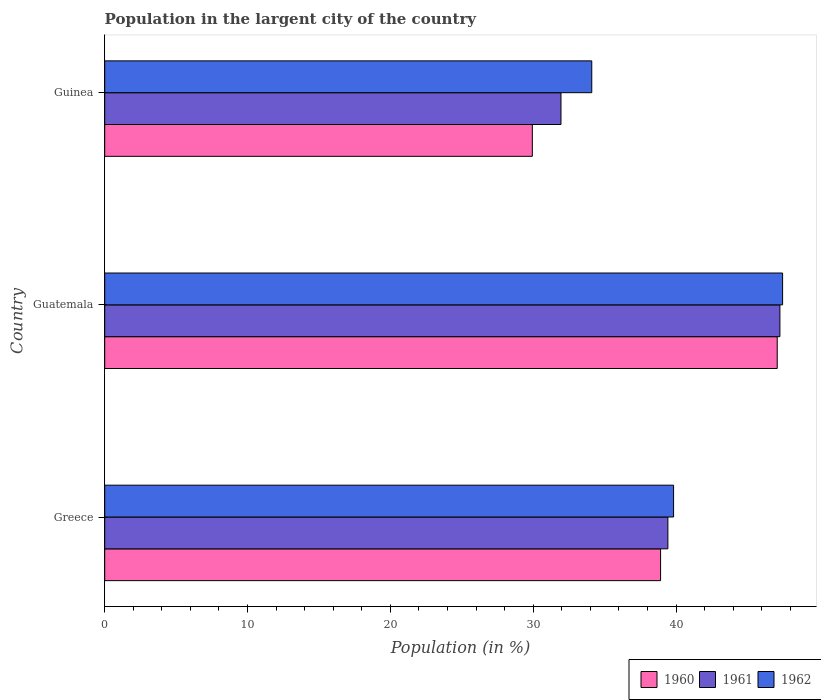How many different coloured bars are there?
Offer a very short reply. 3. How many groups of bars are there?
Provide a short and direct response. 3. Are the number of bars per tick equal to the number of legend labels?
Ensure brevity in your answer.  Yes. Are the number of bars on each tick of the Y-axis equal?
Provide a short and direct response. Yes. How many bars are there on the 2nd tick from the top?
Your answer should be very brief. 3. How many bars are there on the 3rd tick from the bottom?
Offer a very short reply. 3. What is the label of the 2nd group of bars from the top?
Offer a terse response. Guatemala. In how many cases, is the number of bars for a given country not equal to the number of legend labels?
Offer a terse response. 0. What is the percentage of population in the largent city in 1962 in Greece?
Your answer should be compact. 39.83. Across all countries, what is the maximum percentage of population in the largent city in 1962?
Your response must be concise. 47.46. Across all countries, what is the minimum percentage of population in the largent city in 1960?
Give a very brief answer. 29.94. In which country was the percentage of population in the largent city in 1962 maximum?
Make the answer very short. Guatemala. In which country was the percentage of population in the largent city in 1962 minimum?
Provide a succinct answer. Guinea. What is the total percentage of population in the largent city in 1960 in the graph?
Keep it short and to the point. 115.94. What is the difference between the percentage of population in the largent city in 1960 in Greece and that in Guinea?
Offer a terse response. 8.98. What is the difference between the percentage of population in the largent city in 1960 in Greece and the percentage of population in the largent city in 1962 in Guinea?
Ensure brevity in your answer.  4.82. What is the average percentage of population in the largent city in 1961 per country?
Your answer should be compact. 39.55. What is the difference between the percentage of population in the largent city in 1960 and percentage of population in the largent city in 1961 in Greece?
Ensure brevity in your answer.  -0.51. In how many countries, is the percentage of population in the largent city in 1961 greater than 44 %?
Offer a very short reply. 1. What is the ratio of the percentage of population in the largent city in 1960 in Guatemala to that in Guinea?
Keep it short and to the point. 1.57. Is the percentage of population in the largent city in 1962 in Guatemala less than that in Guinea?
Your answer should be very brief. No. Is the difference between the percentage of population in the largent city in 1960 in Greece and Guinea greater than the difference between the percentage of population in the largent city in 1961 in Greece and Guinea?
Your answer should be very brief. Yes. What is the difference between the highest and the second highest percentage of population in the largent city in 1962?
Offer a very short reply. 7.63. What is the difference between the highest and the lowest percentage of population in the largent city in 1960?
Provide a short and direct response. 17.15. Is the sum of the percentage of population in the largent city in 1962 in Greece and Guatemala greater than the maximum percentage of population in the largent city in 1960 across all countries?
Ensure brevity in your answer.  Yes. What does the 1st bar from the bottom in Guinea represents?
Give a very brief answer. 1960. Are all the bars in the graph horizontal?
Provide a short and direct response. Yes. Are the values on the major ticks of X-axis written in scientific E-notation?
Keep it short and to the point. No. Where does the legend appear in the graph?
Your answer should be very brief. Bottom right. How many legend labels are there?
Give a very brief answer. 3. What is the title of the graph?
Offer a terse response. Population in the largent city of the country. What is the label or title of the Y-axis?
Your answer should be very brief. Country. What is the Population (in %) in 1960 in Greece?
Make the answer very short. 38.92. What is the Population (in %) of 1961 in Greece?
Give a very brief answer. 39.43. What is the Population (in %) of 1962 in Greece?
Keep it short and to the point. 39.83. What is the Population (in %) in 1960 in Guatemala?
Offer a terse response. 47.08. What is the Population (in %) in 1961 in Guatemala?
Ensure brevity in your answer.  47.27. What is the Population (in %) in 1962 in Guatemala?
Give a very brief answer. 47.46. What is the Population (in %) in 1960 in Guinea?
Provide a short and direct response. 29.94. What is the Population (in %) in 1961 in Guinea?
Offer a very short reply. 31.94. What is the Population (in %) of 1962 in Guinea?
Your response must be concise. 34.1. Across all countries, what is the maximum Population (in %) of 1960?
Keep it short and to the point. 47.08. Across all countries, what is the maximum Population (in %) of 1961?
Your response must be concise. 47.27. Across all countries, what is the maximum Population (in %) in 1962?
Provide a succinct answer. 47.46. Across all countries, what is the minimum Population (in %) in 1960?
Your response must be concise. 29.94. Across all countries, what is the minimum Population (in %) in 1961?
Provide a short and direct response. 31.94. Across all countries, what is the minimum Population (in %) in 1962?
Give a very brief answer. 34.1. What is the total Population (in %) in 1960 in the graph?
Provide a succinct answer. 115.94. What is the total Population (in %) in 1961 in the graph?
Offer a terse response. 118.65. What is the total Population (in %) in 1962 in the graph?
Your answer should be compact. 121.39. What is the difference between the Population (in %) in 1960 in Greece and that in Guatemala?
Offer a very short reply. -8.17. What is the difference between the Population (in %) of 1961 in Greece and that in Guatemala?
Your answer should be compact. -7.84. What is the difference between the Population (in %) in 1962 in Greece and that in Guatemala?
Offer a terse response. -7.63. What is the difference between the Population (in %) of 1960 in Greece and that in Guinea?
Your answer should be compact. 8.98. What is the difference between the Population (in %) in 1961 in Greece and that in Guinea?
Give a very brief answer. 7.48. What is the difference between the Population (in %) of 1962 in Greece and that in Guinea?
Make the answer very short. 5.73. What is the difference between the Population (in %) in 1960 in Guatemala and that in Guinea?
Offer a terse response. 17.15. What is the difference between the Population (in %) in 1961 in Guatemala and that in Guinea?
Provide a short and direct response. 15.33. What is the difference between the Population (in %) in 1962 in Guatemala and that in Guinea?
Your answer should be very brief. 13.36. What is the difference between the Population (in %) in 1960 in Greece and the Population (in %) in 1961 in Guatemala?
Offer a very short reply. -8.35. What is the difference between the Population (in %) in 1960 in Greece and the Population (in %) in 1962 in Guatemala?
Provide a short and direct response. -8.54. What is the difference between the Population (in %) of 1961 in Greece and the Population (in %) of 1962 in Guatemala?
Provide a short and direct response. -8.03. What is the difference between the Population (in %) in 1960 in Greece and the Population (in %) in 1961 in Guinea?
Offer a very short reply. 6.97. What is the difference between the Population (in %) in 1960 in Greece and the Population (in %) in 1962 in Guinea?
Keep it short and to the point. 4.82. What is the difference between the Population (in %) of 1961 in Greece and the Population (in %) of 1962 in Guinea?
Make the answer very short. 5.33. What is the difference between the Population (in %) in 1960 in Guatemala and the Population (in %) in 1961 in Guinea?
Provide a succinct answer. 15.14. What is the difference between the Population (in %) of 1960 in Guatemala and the Population (in %) of 1962 in Guinea?
Provide a short and direct response. 12.98. What is the difference between the Population (in %) in 1961 in Guatemala and the Population (in %) in 1962 in Guinea?
Give a very brief answer. 13.17. What is the average Population (in %) in 1960 per country?
Provide a short and direct response. 38.65. What is the average Population (in %) in 1961 per country?
Ensure brevity in your answer.  39.55. What is the average Population (in %) of 1962 per country?
Your answer should be compact. 40.46. What is the difference between the Population (in %) in 1960 and Population (in %) in 1961 in Greece?
Keep it short and to the point. -0.51. What is the difference between the Population (in %) in 1960 and Population (in %) in 1962 in Greece?
Provide a short and direct response. -0.91. What is the difference between the Population (in %) of 1961 and Population (in %) of 1962 in Greece?
Provide a short and direct response. -0.4. What is the difference between the Population (in %) in 1960 and Population (in %) in 1961 in Guatemala?
Ensure brevity in your answer.  -0.19. What is the difference between the Population (in %) in 1960 and Population (in %) in 1962 in Guatemala?
Offer a very short reply. -0.38. What is the difference between the Population (in %) of 1961 and Population (in %) of 1962 in Guatemala?
Keep it short and to the point. -0.19. What is the difference between the Population (in %) in 1960 and Population (in %) in 1961 in Guinea?
Ensure brevity in your answer.  -2.01. What is the difference between the Population (in %) in 1960 and Population (in %) in 1962 in Guinea?
Provide a short and direct response. -4.16. What is the difference between the Population (in %) in 1961 and Population (in %) in 1962 in Guinea?
Provide a short and direct response. -2.15. What is the ratio of the Population (in %) of 1960 in Greece to that in Guatemala?
Give a very brief answer. 0.83. What is the ratio of the Population (in %) of 1961 in Greece to that in Guatemala?
Provide a succinct answer. 0.83. What is the ratio of the Population (in %) of 1962 in Greece to that in Guatemala?
Ensure brevity in your answer.  0.84. What is the ratio of the Population (in %) in 1960 in Greece to that in Guinea?
Offer a terse response. 1.3. What is the ratio of the Population (in %) of 1961 in Greece to that in Guinea?
Provide a short and direct response. 1.23. What is the ratio of the Population (in %) in 1962 in Greece to that in Guinea?
Provide a succinct answer. 1.17. What is the ratio of the Population (in %) of 1960 in Guatemala to that in Guinea?
Your answer should be compact. 1.57. What is the ratio of the Population (in %) in 1961 in Guatemala to that in Guinea?
Your answer should be compact. 1.48. What is the ratio of the Population (in %) in 1962 in Guatemala to that in Guinea?
Your answer should be compact. 1.39. What is the difference between the highest and the second highest Population (in %) in 1960?
Keep it short and to the point. 8.17. What is the difference between the highest and the second highest Population (in %) in 1961?
Your answer should be compact. 7.84. What is the difference between the highest and the second highest Population (in %) in 1962?
Give a very brief answer. 7.63. What is the difference between the highest and the lowest Population (in %) in 1960?
Provide a succinct answer. 17.15. What is the difference between the highest and the lowest Population (in %) of 1961?
Offer a very short reply. 15.33. What is the difference between the highest and the lowest Population (in %) in 1962?
Give a very brief answer. 13.36. 